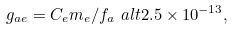<formula> <loc_0><loc_0><loc_500><loc_500>g _ { a e } = C _ { e } m _ { e } / f _ { a } \ a l t 2 . 5 \times 1 0 ^ { - 1 3 } ,</formula> 